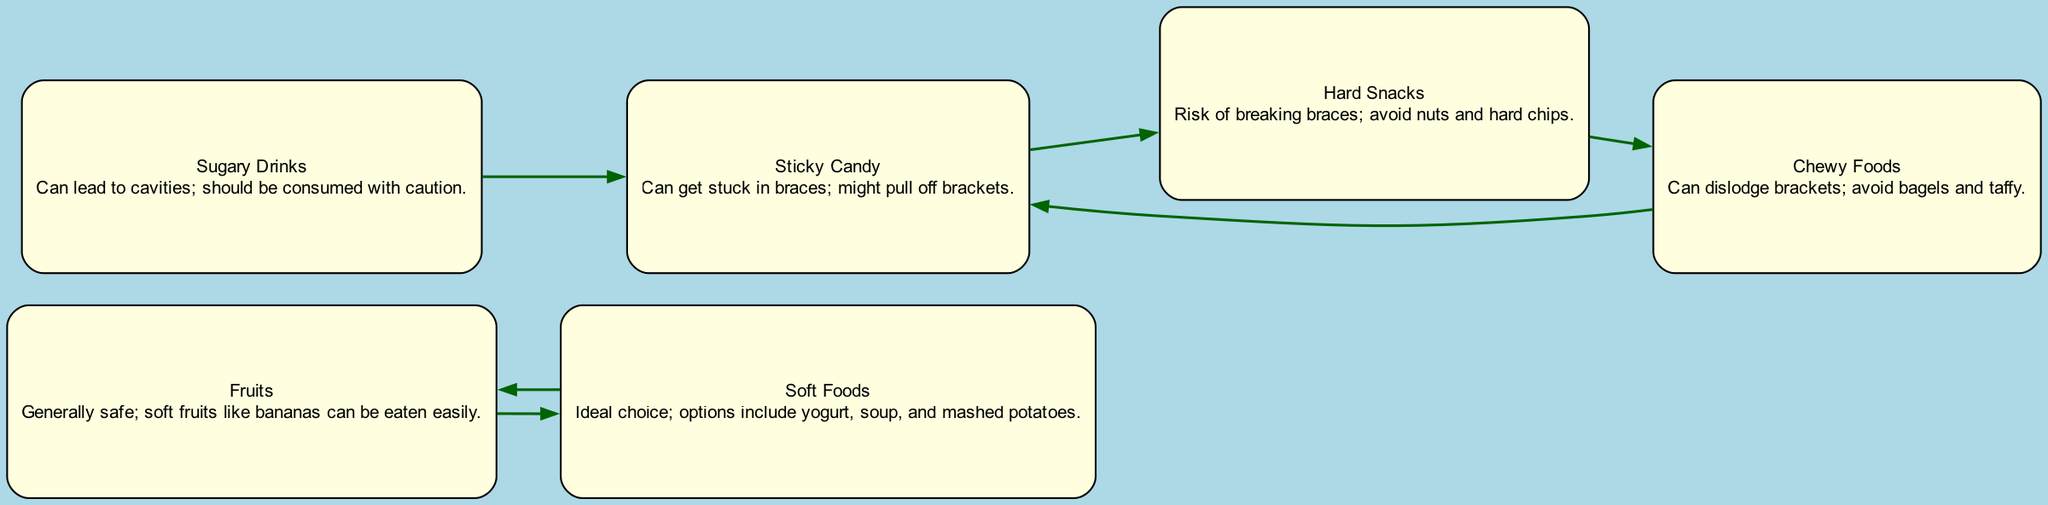What is the total number of food options listed in the diagram? The diagram lists six food options: Fruits, Sticky Candy, Hard Snacks, Soft Foods, Sugary Drinks, and Chewy Foods. Therefore, the total number of food options is six.
Answer: 6 Which food option is described as the ideal choice for braces wearers? The node labeled "Soft Foods" is described as the ideal choice for braces wearers, with options such as yogurt, soup, and mashed potatoes.
Answer: Soft Foods How many edges are there connecting food options in the diagram? The diagram contains five edges which represent the connections between the different food options listed.
Answer: 5 What food option can potentially dislodge brackets? The "Chewy Foods" option is linked to the risk of dislodging brackets, which includes items like bagels and taffy.
Answer: Chewy Foods What is the relationship between "Sugary Drinks" and "Sticky Candy"? In the diagram, there is a direct connection (edge) from "Sugary Drinks" to "Sticky Candy," indicating that consuming sugary drinks can lead to sticky candy consumption.
Answer: Sugary Drinks → Sticky Candy Which food option is connected to both "Sticky Candy" and "Hard Snacks"? "Sticky Candy" is linked to "Hard Snacks" through a directed edge indicating that sticky candy can lead to or be associated with hard snacks.
Answer: Sticky Candy Which food options are considered risky to eat for braces wearers? The risky options for braces wearers, as represented in the diagram, include "Sticky Candy," "Hard Snacks," and "Chewy Foods."
Answer: Sticky Candy, Hard Snacks, Chewy Foods Which food option can be consumed after eating "Fruits"? The edge from "Fruits" to "Soft Foods" indicates that after eating fruits, one can also eat soft foods as they are related choices.
Answer: Soft Foods If a person eats "Hard Snacks," which other food option should they avoid? "Hard Snacks" is connected to "Chewy Foods," suggesting that if someone eats hard snacks, they should also avoid chewier options to prevent dislodging brackets.
Answer: Chewy Foods 